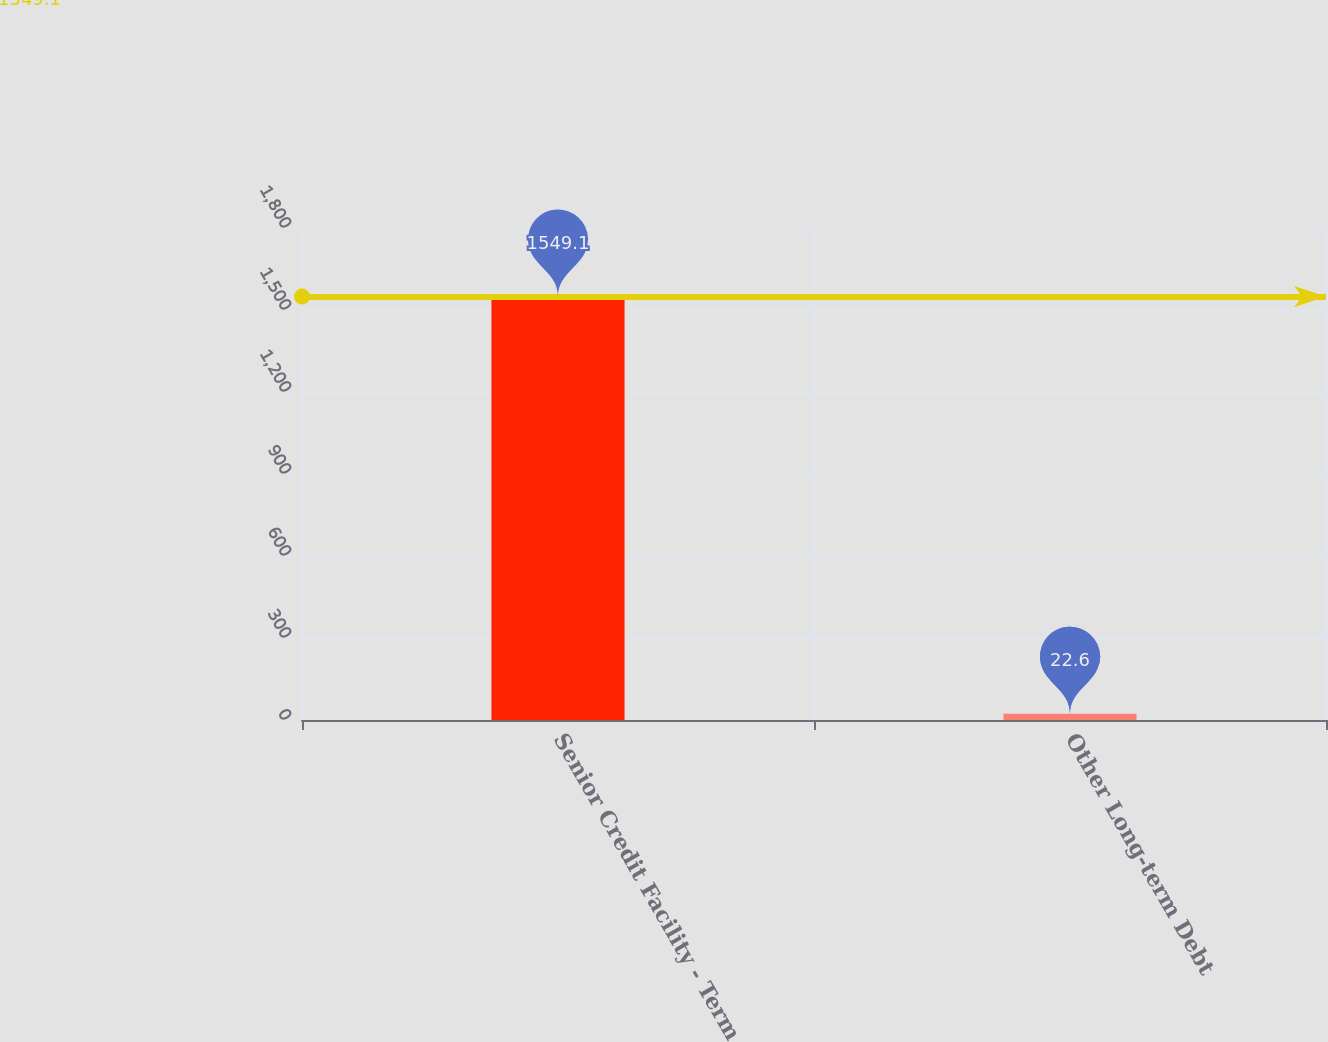<chart> <loc_0><loc_0><loc_500><loc_500><bar_chart><fcel>Senior Credit Facility - Term<fcel>Other Long-term Debt<nl><fcel>1549.1<fcel>22.6<nl></chart> 